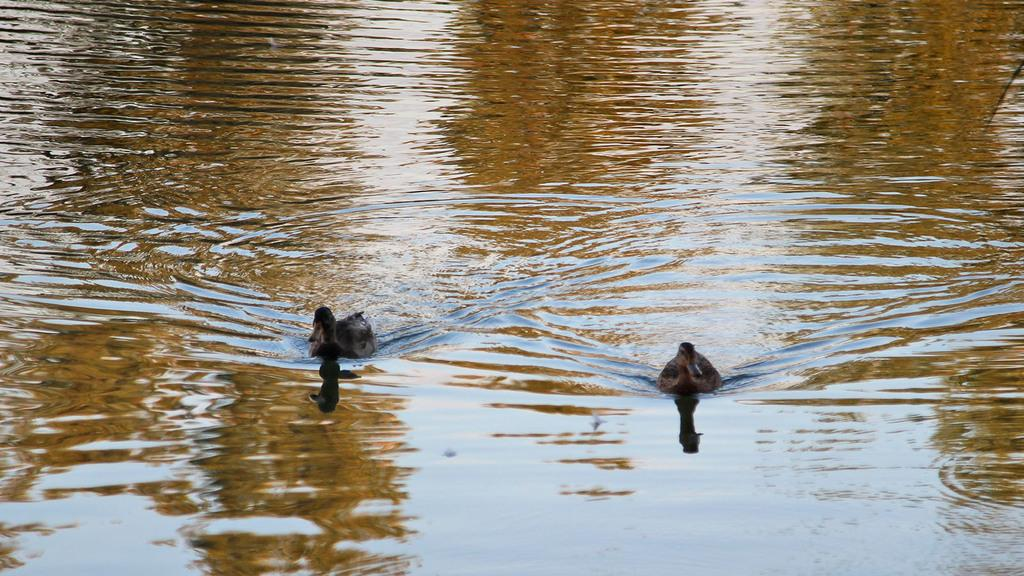What animals are present in the image? There are two ducks in the image. Where are the ducks located? The ducks are in the water. What type of police station can be seen in the image? There is no police station present in the image; it features two ducks in the water. Can you confirm the existence of a market in the image? There is no market present in the image; it features two ducks in the water. 